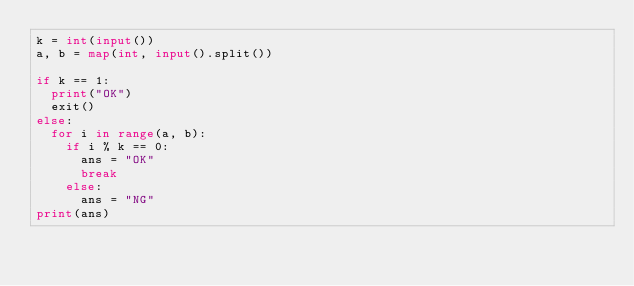Convert code to text. <code><loc_0><loc_0><loc_500><loc_500><_Python_>k = int(input())
a, b = map(int, input().split())

if k == 1:
  print("OK")
  exit()
else:
  for i in range(a, b):
    if i % k == 0:
      ans = "OK"
      break
    else:
      ans = "NG"
print(ans)</code> 